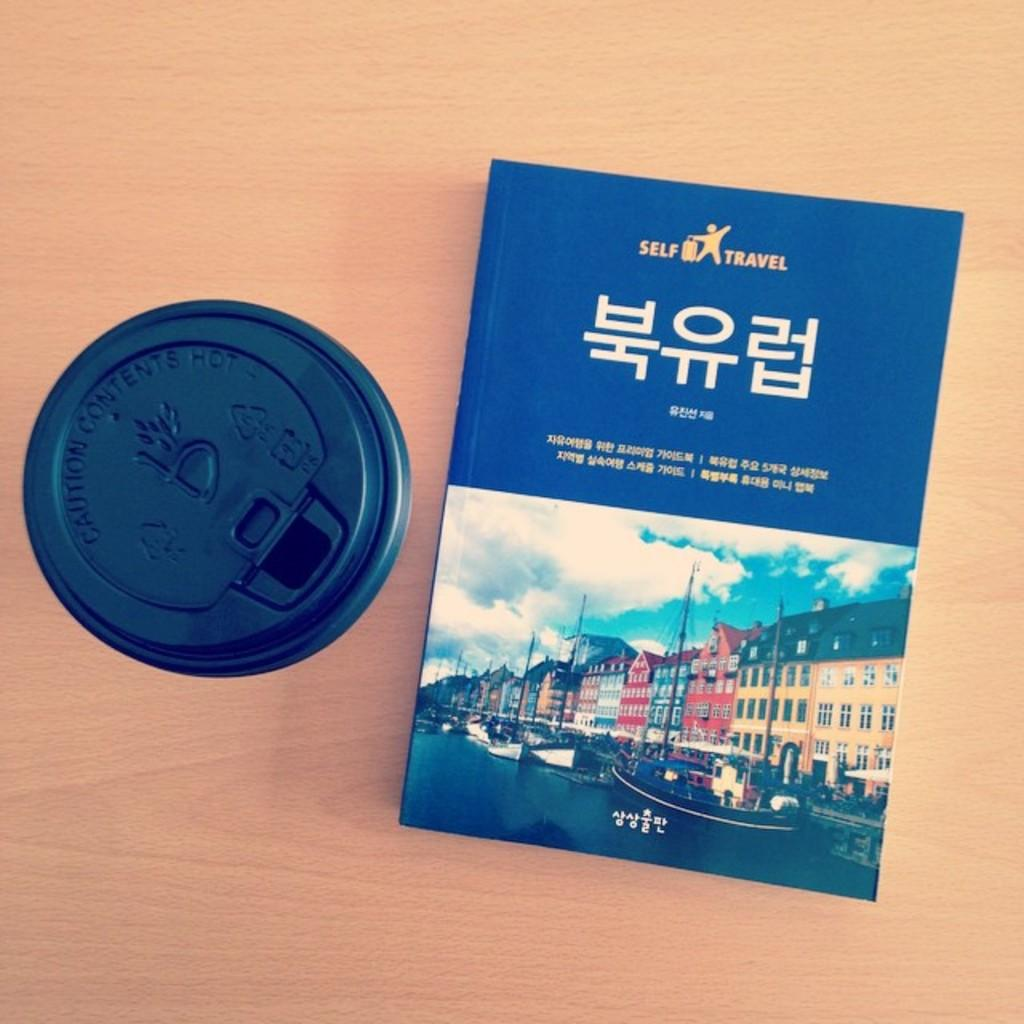<image>
Share a concise interpretation of the image provided. A vacation guide book is published by a company called Self Travel. 